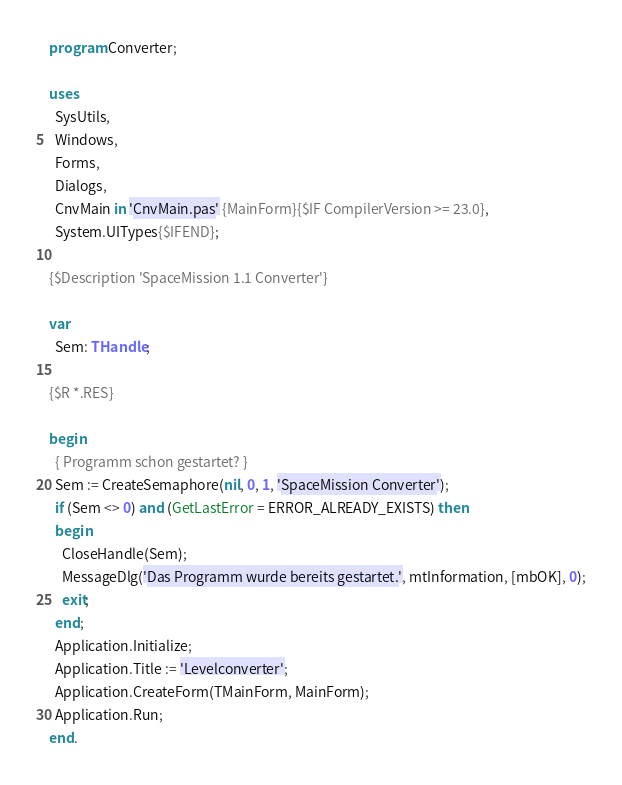Convert code to text. <code><loc_0><loc_0><loc_500><loc_500><_Pascal_>program Converter;

uses
  SysUtils,
  Windows,
  Forms,
  Dialogs,
  CnvMain in 'CnvMain.pas' {MainForm}{$IF CompilerVersion >= 23.0},
  System.UITypes{$IFEND};

{$Description 'SpaceMission 1.1 Converter'}

var
  Sem: THandle;

{$R *.RES}

begin
  { Programm schon gestartet? }
  Sem := CreateSemaphore(nil, 0, 1, 'SpaceMission Converter');
  if (Sem <> 0) and (GetLastError = ERROR_ALREADY_EXISTS) then
  begin
    CloseHandle(Sem);
    MessageDlg('Das Programm wurde bereits gestartet.', mtInformation, [mbOK], 0);
    exit;
  end;
  Application.Initialize;
  Application.Title := 'Levelconverter';
  Application.CreateForm(TMainForm, MainForm);
  Application.Run;
end.
</code> 